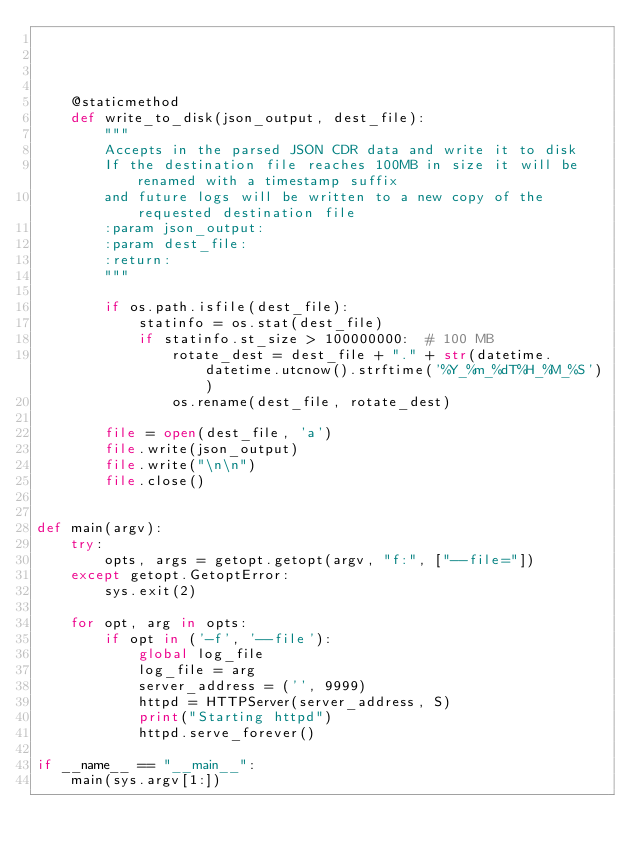<code> <loc_0><loc_0><loc_500><loc_500><_Python_>

    

    @staticmethod
    def write_to_disk(json_output, dest_file):
        """
        Accepts in the parsed JSON CDR data and write it to disk
        If the destination file reaches 100MB in size it will be renamed with a timestamp suffix
        and future logs will be written to a new copy of the requested destination file
        :param json_output:
        :param dest_file:
        :return:
        """

        if os.path.isfile(dest_file):
            statinfo = os.stat(dest_file)
            if statinfo.st_size > 100000000:  # 100 MB
                rotate_dest = dest_file + "." + str(datetime.datetime.utcnow().strftime('%Y_%m_%dT%H_%M_%S'))
                os.rename(dest_file, rotate_dest)

        file = open(dest_file, 'a')
        file.write(json_output)
        file.write("\n\n")
        file.close()


def main(argv):
    try:
        opts, args = getopt.getopt(argv, "f:", ["--file="])
    except getopt.GetoptError:
        sys.exit(2)

    for opt, arg in opts:
        if opt in ('-f', '--file'):
            global log_file
            log_file = arg
            server_address = ('', 9999)
            httpd = HTTPServer(server_address, S)
            print("Starting httpd")
            httpd.serve_forever()

if __name__ == "__main__":
    main(sys.argv[1:])
</code> 